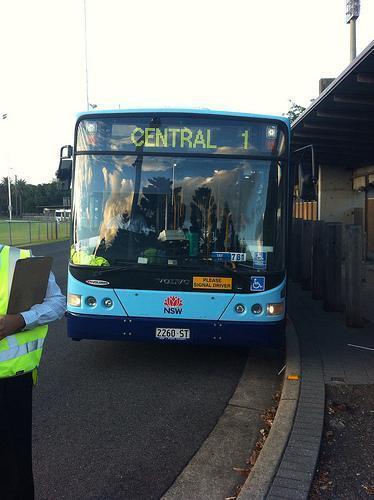How many people are in the picture?
Give a very brief answer. 2. 